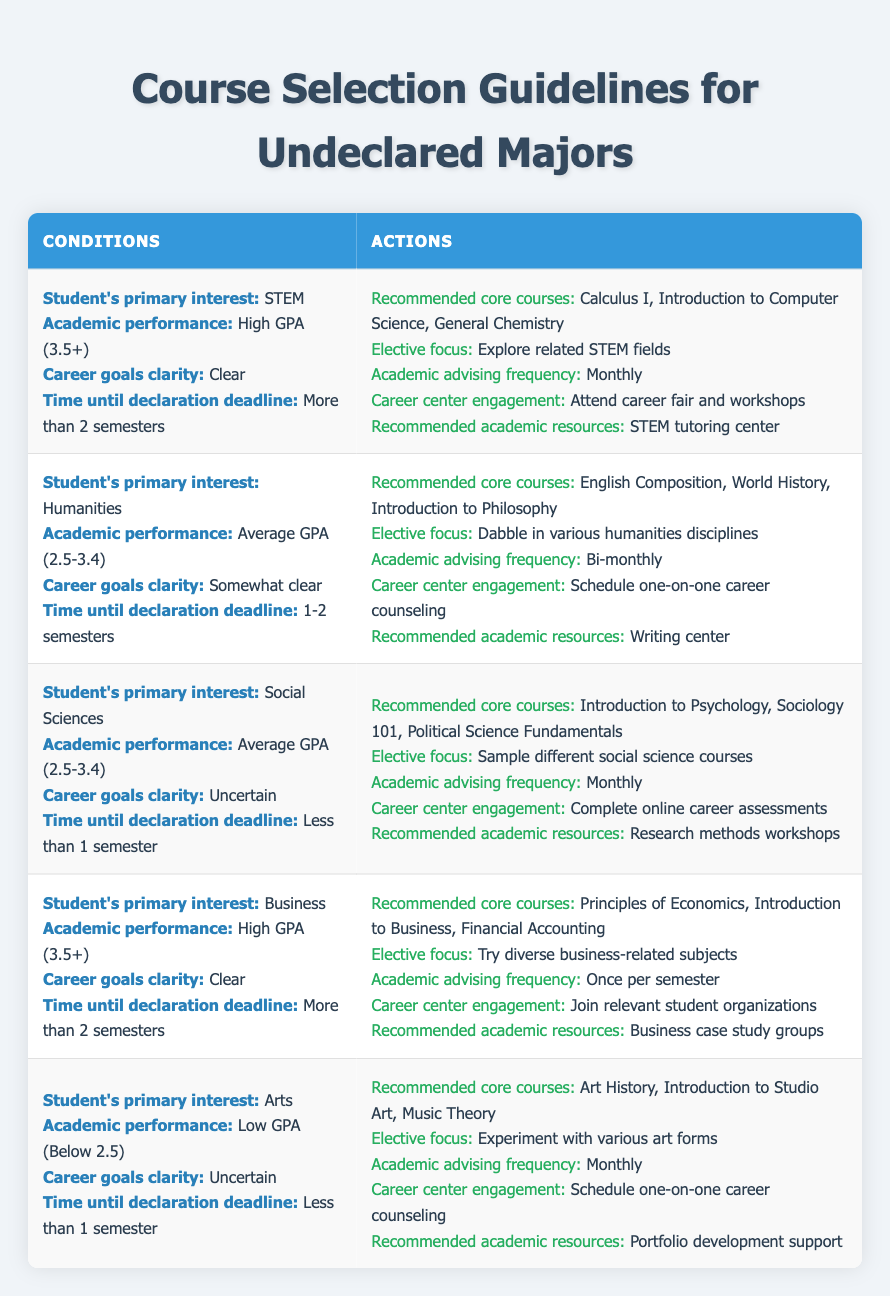What recommended core courses are suggested for students interested in STEM with high GPA and clear career goals? The table indicates that for students whose primary interest is STEM, with a high GPA (3.5+) and clear career goals, the recommended core courses are Calculus I, Introduction to Computer Science, and General Chemistry.
Answer: Calculus I, Introduction to Computer Science, General Chemistry Which academic advising frequency is suggested for students interested in Business with a high GPA and clear career goals? Referring to the row for students interested in Business, those with a high GPA (3.5+) and clear career goals are advised to have academic advising once per semester.
Answer: Once per semester Are students with an uncertain career goal focused on sampling different social science courses? Yes, the data shows that for students interested in Social Sciences with an uncertain career goal, the elective focus is to sample different social science courses.
Answer: Yes What is the relationship between academic performance and recommended academic resources for students in the Arts with a low GPA? For students in the Arts with a low GPA (below 2.5), the recommended academic resources are portfolio development support. This suggests that as academic performance decreases, the focus shifts towards resources that help in honing practical skills, such as portfolio development.
Answer: Portfolio development support What are the total number of rows representing students with a clear career goal across all majors? There are two rows with a clear career goal: one for STEM and one for Business, bringing the total to two. This requires counting the rows that specifically mention "Clear" under the career goals clarity condition.
Answer: 2 Which elective focus is recommended for humanities students with an average GPA and somewhat clear career goals, and what is the academic advising frequency suggested for these students? The elective focus recommended for humanities students with an average GPA (2.5-3.4) and somewhat clear career goals is to dabble in various humanities disciplines, with academic advising frequency suggested as bi-monthly. This is gathered by looking at the specific row matching the described conditions.
Answer: Dabble in various humanities disciplines; Bi-monthly For students with a low GPA interested in Social Sciences, what is the career center engagement strategy? The table specifies that students with a low GPA (below 2.5) interested in Social Sciences should complete online career assessments as their career center engagement strategy. This is found by examining the appropriate row for the specified conditions.
Answer: Complete online career assessments How many months of academic advising are recommended for Arts students with uncertain career goals and a low GPA? Arts students with uncertain career goals and a low GPA (below 2.5) are recommended to have monthly academic advising. This is derived from the row indicating the actions linked to those specific conditions.
Answer: Monthly 